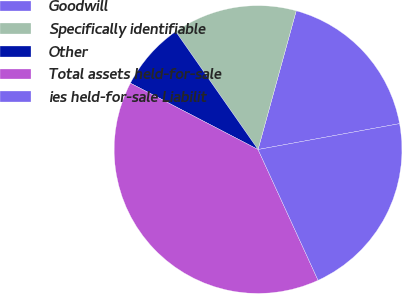Convert chart to OTSL. <chart><loc_0><loc_0><loc_500><loc_500><pie_chart><fcel>Goodwill<fcel>Specifically identifiable<fcel>Other<fcel>Total assets held-for-sale<fcel>ies held-for-sale Liabilit<nl><fcel>17.85%<fcel>13.97%<fcel>7.67%<fcel>39.48%<fcel>21.03%<nl></chart> 